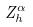<formula> <loc_0><loc_0><loc_500><loc_500>Z _ { h } ^ { \alpha }</formula> 